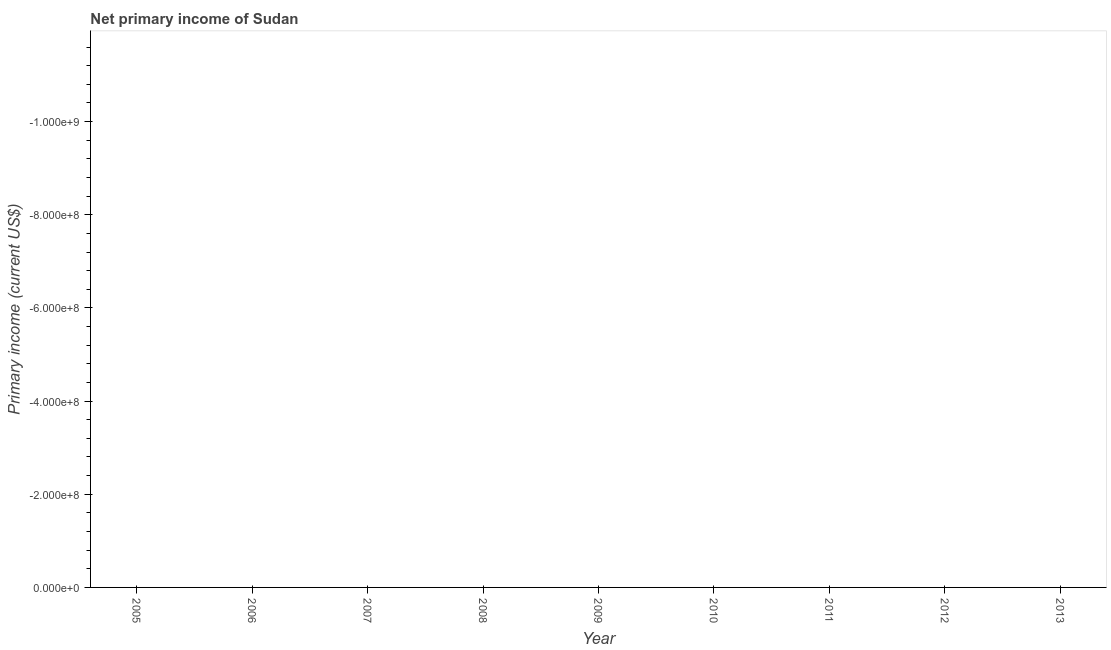What is the amount of primary income in 2013?
Make the answer very short. 0. Across all years, what is the minimum amount of primary income?
Provide a succinct answer. 0. What is the sum of the amount of primary income?
Provide a succinct answer. 0. What is the average amount of primary income per year?
Make the answer very short. 0. What is the median amount of primary income?
Offer a terse response. 0. In how many years, is the amount of primary income greater than the average amount of primary income taken over all years?
Your answer should be compact. 0. How many lines are there?
Keep it short and to the point. 0. Are the values on the major ticks of Y-axis written in scientific E-notation?
Your answer should be very brief. Yes. Does the graph contain grids?
Offer a very short reply. No. What is the title of the graph?
Your answer should be compact. Net primary income of Sudan. What is the label or title of the X-axis?
Your response must be concise. Year. What is the label or title of the Y-axis?
Provide a short and direct response. Primary income (current US$). What is the Primary income (current US$) in 2005?
Provide a succinct answer. 0. What is the Primary income (current US$) of 2006?
Keep it short and to the point. 0. What is the Primary income (current US$) of 2008?
Offer a terse response. 0. What is the Primary income (current US$) in 2010?
Your response must be concise. 0. What is the Primary income (current US$) of 2011?
Your answer should be compact. 0. What is the Primary income (current US$) of 2012?
Your response must be concise. 0. 